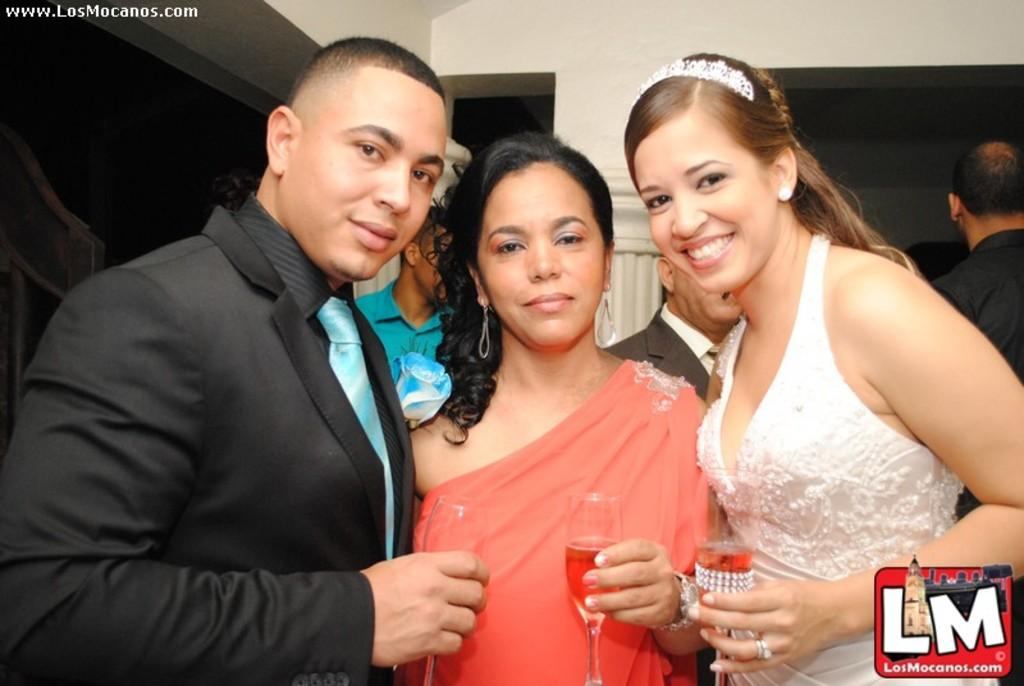How many people are in the image? There are people standing in the image. Can you describe the clothing of one of the people? One person is wearing a peach-colored dress. What is the person in the peach-colored dress holding? The person in the peach-colored dress is holding a glass. What can be seen in the background of the image? There is a cream-colored pillar in the background of the image. What type of achievement is the giraffe celebrating in the image? There is no giraffe present in the image, so it is not possible to determine any achievements being celebrated. 